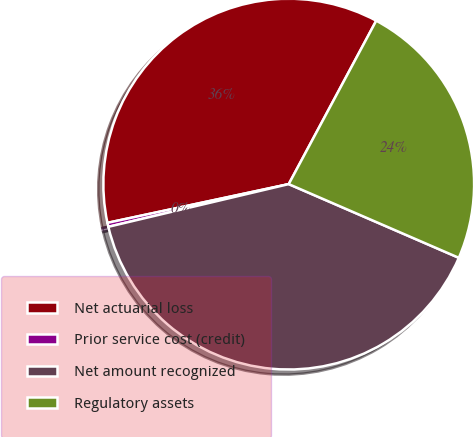Convert chart. <chart><loc_0><loc_0><loc_500><loc_500><pie_chart><fcel>Net actuarial loss<fcel>Prior service cost (credit)<fcel>Net amount recognized<fcel>Regulatory assets<nl><fcel>36.17%<fcel>0.35%<fcel>39.79%<fcel>23.68%<nl></chart> 